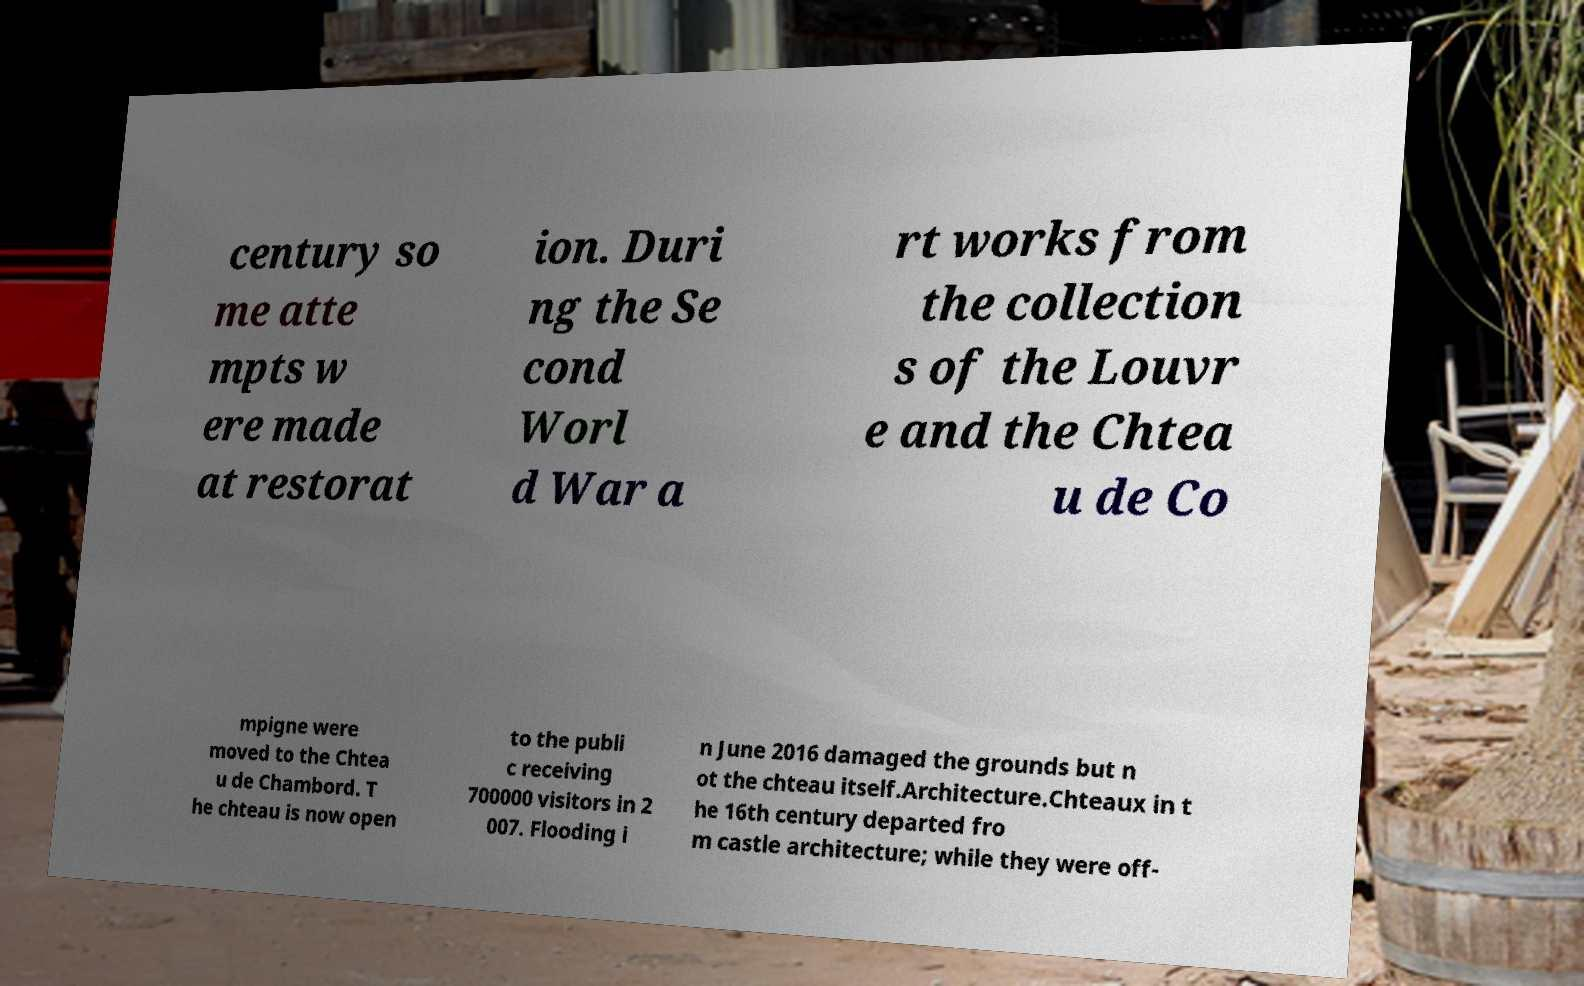Could you extract and type out the text from this image? century so me atte mpts w ere made at restorat ion. Duri ng the Se cond Worl d War a rt works from the collection s of the Louvr e and the Chtea u de Co mpigne were moved to the Chtea u de Chambord. T he chteau is now open to the publi c receiving 700000 visitors in 2 007. Flooding i n June 2016 damaged the grounds but n ot the chteau itself.Architecture.Chteaux in t he 16th century departed fro m castle architecture; while they were off- 